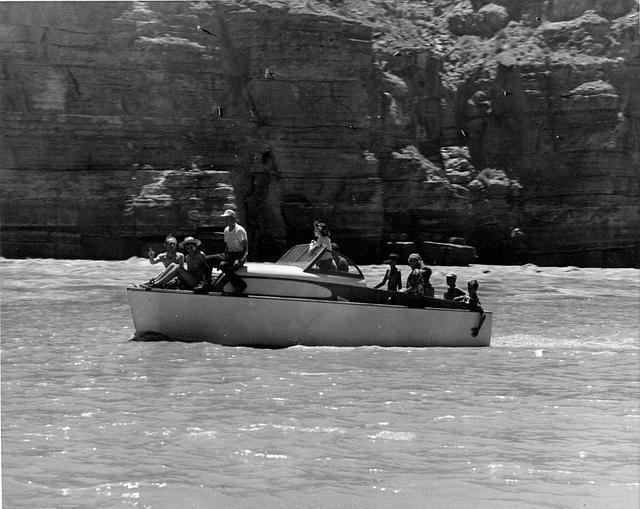How many boats are in the photo?
Give a very brief answer. 2. 